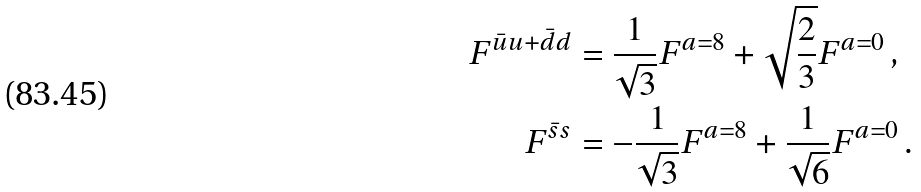Convert formula to latex. <formula><loc_0><loc_0><loc_500><loc_500>F ^ { \bar { u } u + \bar { d } d } & = \frac { 1 } { \sqrt { 3 } } F ^ { a = 8 } + \sqrt { \frac { 2 } { 3 } } F ^ { a = 0 } \, , \\ F ^ { \bar { s } s } & = - \frac { 1 } { \sqrt { 3 } } F ^ { a = 8 } + \frac { 1 } { \sqrt { 6 } } F ^ { a = 0 } \, .</formula> 